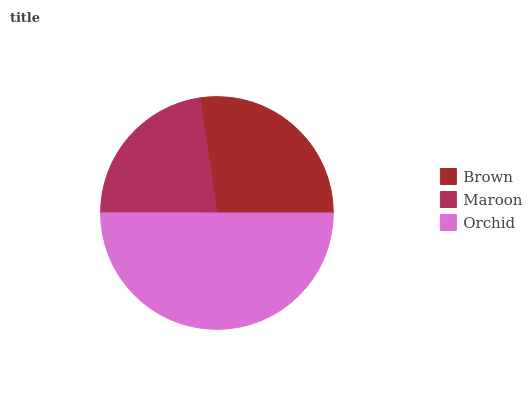Is Maroon the minimum?
Answer yes or no. Yes. Is Orchid the maximum?
Answer yes or no. Yes. Is Orchid the minimum?
Answer yes or no. No. Is Maroon the maximum?
Answer yes or no. No. Is Orchid greater than Maroon?
Answer yes or no. Yes. Is Maroon less than Orchid?
Answer yes or no. Yes. Is Maroon greater than Orchid?
Answer yes or no. No. Is Orchid less than Maroon?
Answer yes or no. No. Is Brown the high median?
Answer yes or no. Yes. Is Brown the low median?
Answer yes or no. Yes. Is Maroon the high median?
Answer yes or no. No. Is Orchid the low median?
Answer yes or no. No. 